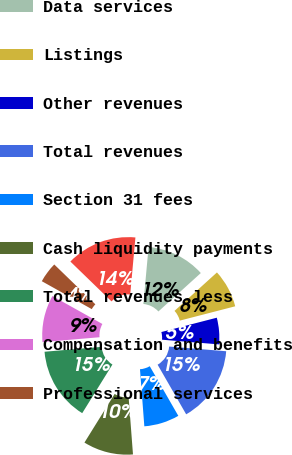Convert chart to OTSL. <chart><loc_0><loc_0><loc_500><loc_500><pie_chart><fcel>Transaction and clearing net<fcel>Data services<fcel>Listings<fcel>Other revenues<fcel>Total revenues<fcel>Section 31 fees<fcel>Cash liquidity payments<fcel>Total revenues less<fcel>Compensation and benefits<fcel>Professional services<nl><fcel>14.2%<fcel>11.83%<fcel>7.69%<fcel>5.33%<fcel>15.38%<fcel>7.1%<fcel>10.06%<fcel>14.79%<fcel>9.47%<fcel>4.14%<nl></chart> 